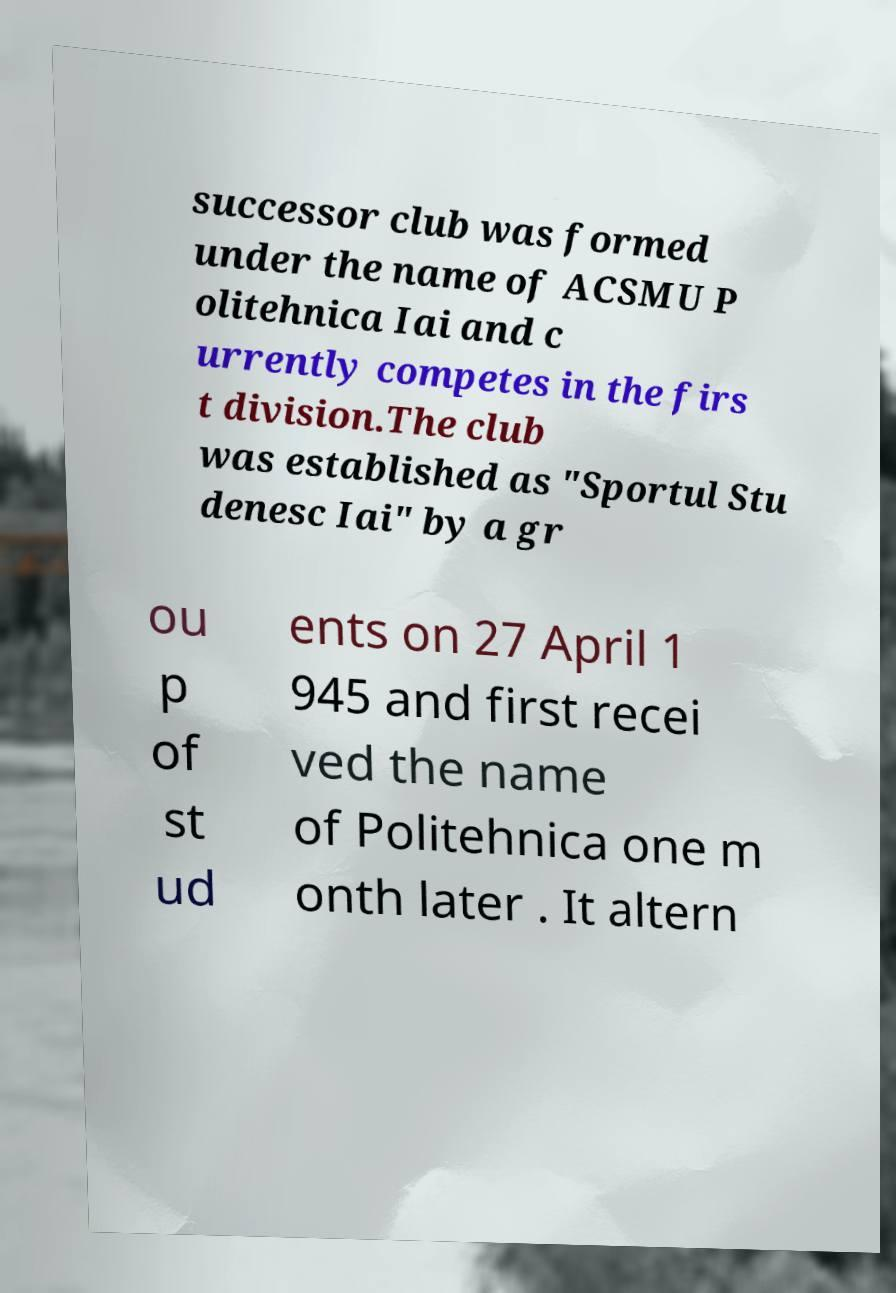What messages or text are displayed in this image? I need them in a readable, typed format. successor club was formed under the name of ACSMU P olitehnica Iai and c urrently competes in the firs t division.The club was established as "Sportul Stu denesc Iai" by a gr ou p of st ud ents on 27 April 1 945 and first recei ved the name of Politehnica one m onth later . It altern 